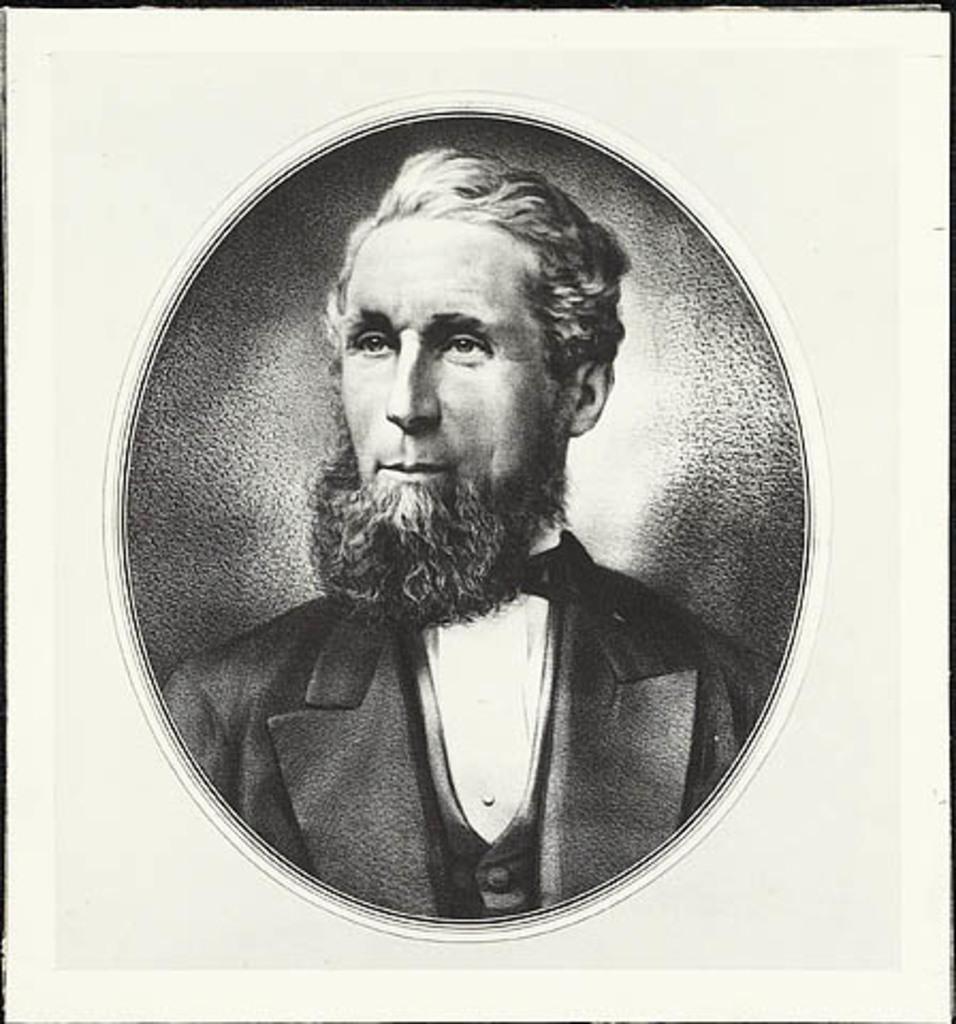Please provide a concise description of this image. In this image there is a frame in which there is a image of the man which is in black and white colour. 